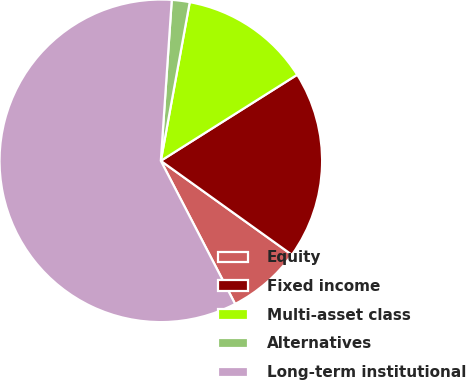<chart> <loc_0><loc_0><loc_500><loc_500><pie_chart><fcel>Equity<fcel>Fixed income<fcel>Multi-asset class<fcel>Alternatives<fcel>Long-term institutional<nl><fcel>7.48%<fcel>18.86%<fcel>13.17%<fcel>1.79%<fcel>58.7%<nl></chart> 